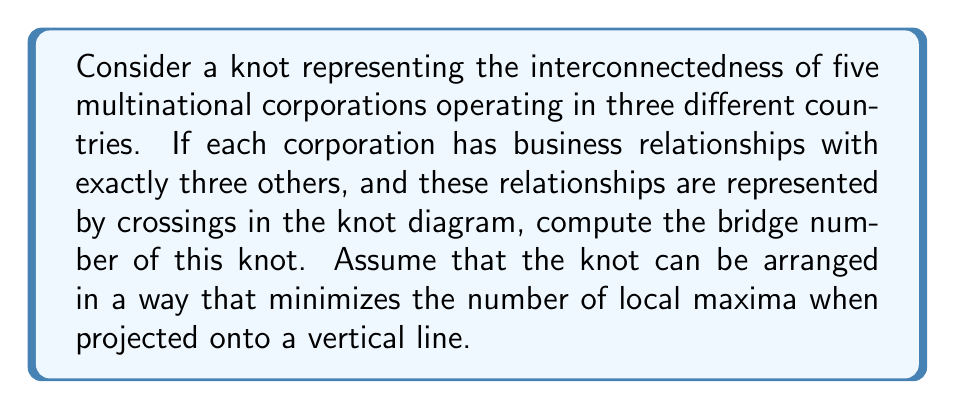Teach me how to tackle this problem. To solve this problem, let's follow these steps:

1. Understand the given information:
   - We have 5 corporations represented in the knot
   - Each corporation has relationships with 3 others
   - Each relationship is represented by a crossing in the knot diagram

2. Calculate the number of crossings:
   - Total relationships = $\frac{5 \times 3}{2} = 7.5$
   - Since we can't have half a crossing, we round up to 8 crossings

3. Recall the definition of bridge number:
   The bridge number of a knot is the minimum number of local maxima in any projection of the knot onto a vertical line.

4. Consider the relationship between crossings and local maxima:
   - In a minimal bridge representation, each "bridge" typically contributes two crossings
   - The number of bridges is usually about half the number of crossings

5. Calculate the bridge number:
   - Estimated bridge number = $\lceil \frac{\text{number of crossings}}{2} \rceil$
   - In this case: $\lceil \frac{8}{2} \rceil = 4$

6. Verify the result:
   - A bridge number of 4 means we can arrange the knot with 4 local maxima
   - This is consistent with representing 5 interconnected entities in 3D space

Therefore, the bridge number of this knot representing the interconnectedness of the five multinational corporations is 4.
Answer: 4 